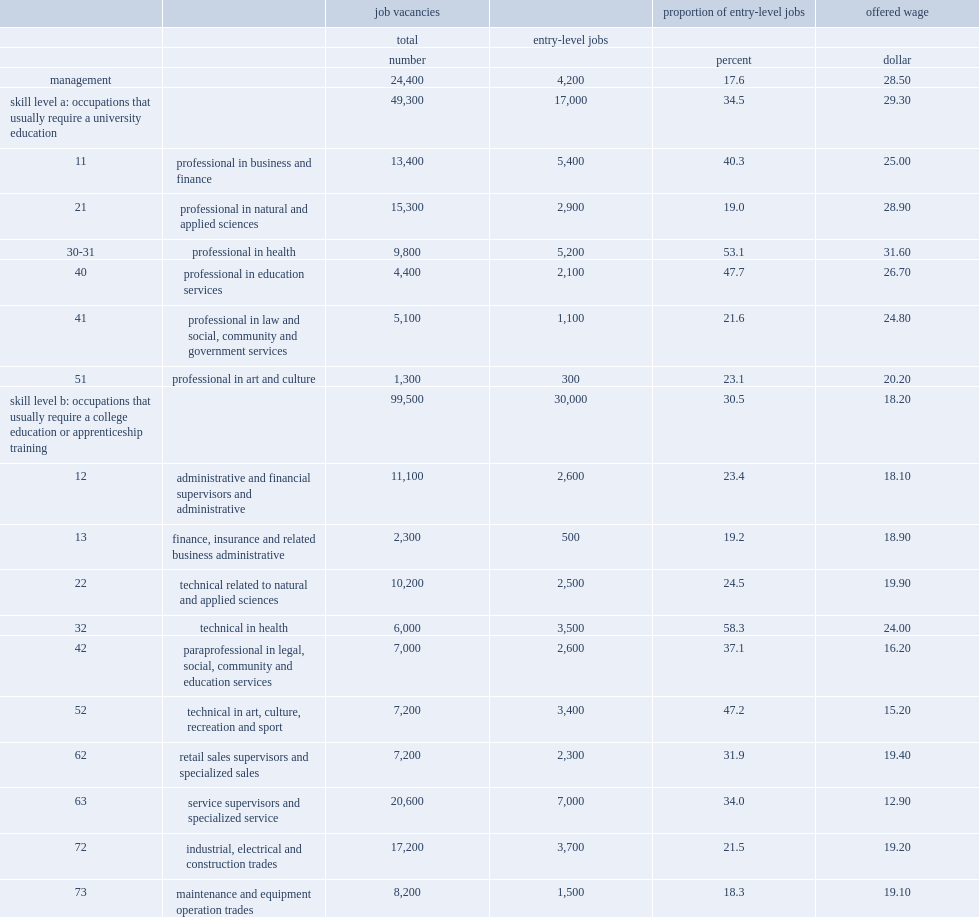For occupations that typically require a university education, what is the proportion of job vacancies that are considered entry-level jobs? 34.5. For professional occupations in health, what is the proportion of job vacancies that are entry-level jobs? 53.1. For professional occupations in education, what is the proportion of job vacancies that are entry-level jobs? 47.7. For professional occupations in business and finance, what is the proportion of job vacancies that are entry-level jobs? 40.3. For occupations that typically require a college diploma or apprenticeship training, what was the proportion of vacancies that were for entry-level positions? 30.5. What was the proportion of vacancies in technical occupations in health that were for entry-level positions? 58.3. What was the proportion of vacancies among processing, manufacturing and utilities supervisors and central control operators that were for entry-level positions? 15.4. What was the proportion of job vacancies of transport and heavy equipment operation and related maintenance that were entry-level jobs? 34.9. What was the proportion of vacancies in office support jobs that were entry-level jobs? 40.4. For occupations that require on-the-job training or no education, what was the proportion of entry-level jobs? 79.5. How many are the offered wages per hour for entry-level positions in occupations that require a university education? 29.3. How many are the offered wages per hour for entry-level positions in occupations that require a college diploma or apprenticeship training? 18.2. How many are the offered wages per hour for entry-level positions in occupations that require a high school diploma? 14. How many are the offered wages per hour for entry-level positions in occupations that require no education? 12.7. How many dollars do entry-level jobs that require a university education in applied and natural sciences offer per hour? 28.9. How many dollars do entry-level jobs that require a college education in applied and natural sciences offer per hour? 19.9. 